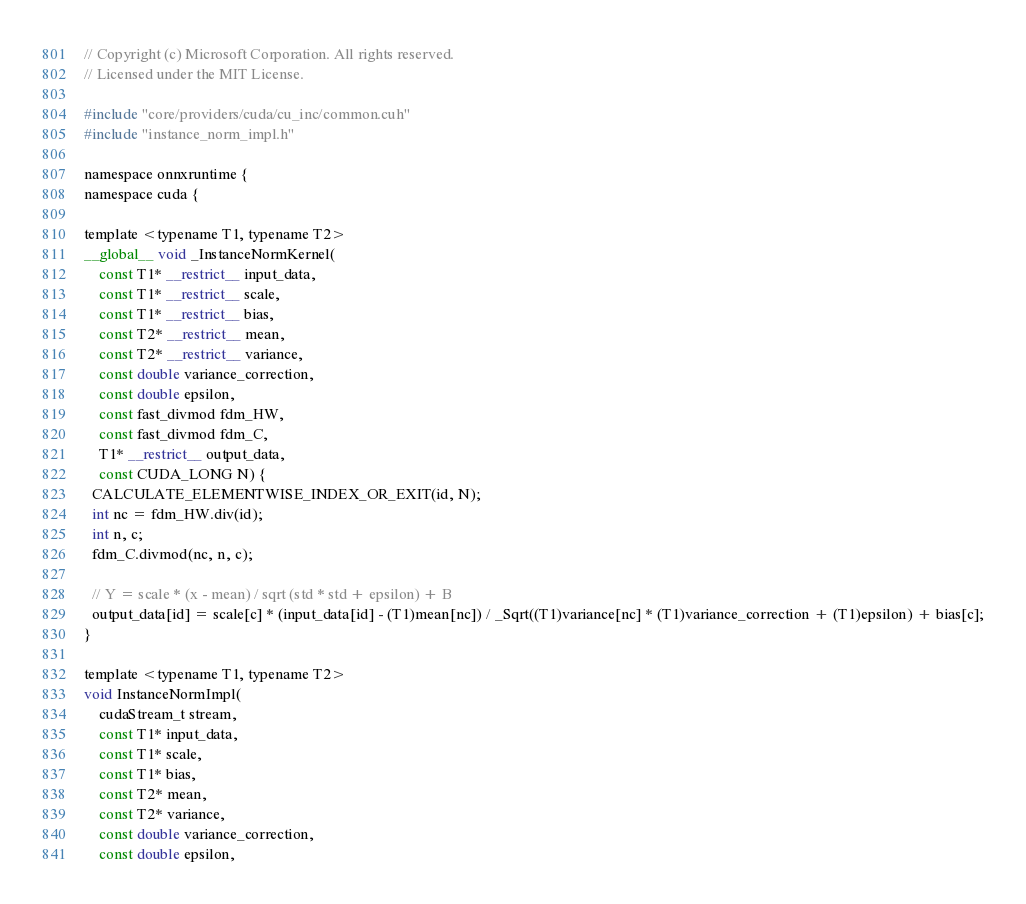Convert code to text. <code><loc_0><loc_0><loc_500><loc_500><_Cuda_>// Copyright (c) Microsoft Corporation. All rights reserved.
// Licensed under the MIT License.

#include "core/providers/cuda/cu_inc/common.cuh"
#include "instance_norm_impl.h"

namespace onnxruntime {
namespace cuda {

template <typename T1, typename T2>
__global__ void _InstanceNormKernel(
    const T1* __restrict__ input_data,
    const T1* __restrict__ scale,
    const T1* __restrict__ bias,
    const T2* __restrict__ mean,
    const T2* __restrict__ variance,
    const double variance_correction,
    const double epsilon,
    const fast_divmod fdm_HW,
    const fast_divmod fdm_C,
    T1* __restrict__ output_data,
    const CUDA_LONG N) {
  CALCULATE_ELEMENTWISE_INDEX_OR_EXIT(id, N);
  int nc = fdm_HW.div(id);
  int n, c;
  fdm_C.divmod(nc, n, c);

  // Y = scale * (x - mean) / sqrt (std * std + epsilon) + B
  output_data[id] = scale[c] * (input_data[id] - (T1)mean[nc]) / _Sqrt((T1)variance[nc] * (T1)variance_correction + (T1)epsilon) + bias[c];
}

template <typename T1, typename T2>
void InstanceNormImpl(
    cudaStream_t stream,
    const T1* input_data,
    const T1* scale,
    const T1* bias,
    const T2* mean,
    const T2* variance,
    const double variance_correction,
    const double epsilon,</code> 